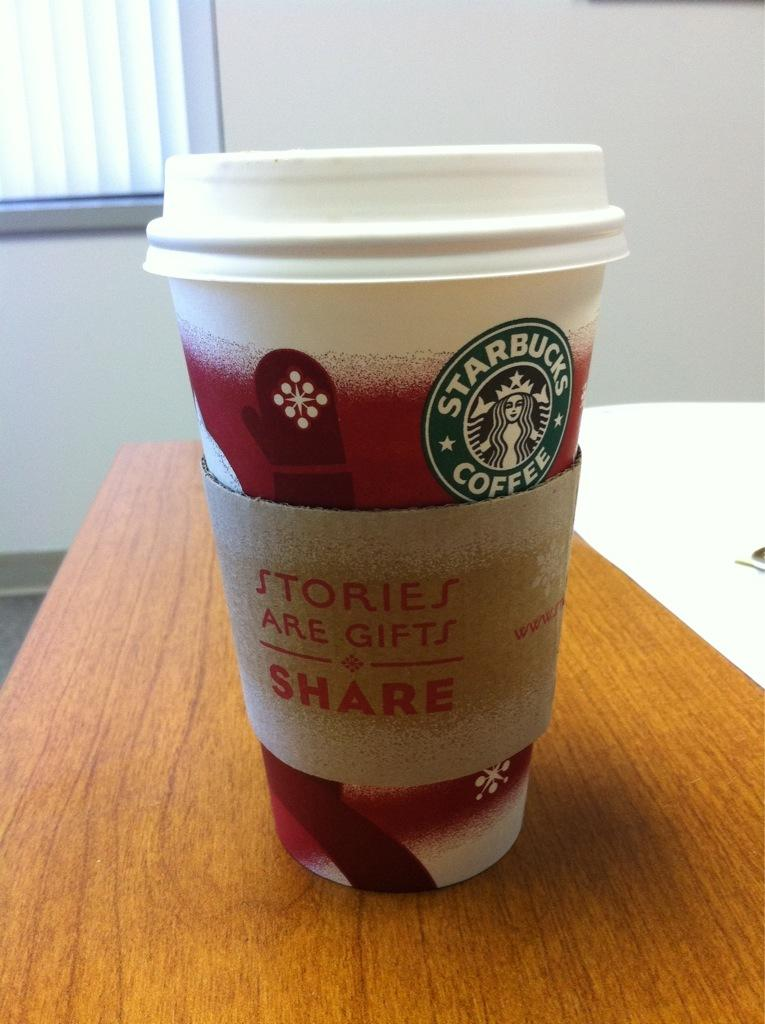What is the main object in the image? There is a Starbucks coffee cup in the image. Where is the coffee cup located? The coffee cup is on a table. What type of grain is visible in the image? There is no grain present in the image; it features a Starbucks coffee cup on a table. How many pockets can be seen on the coffee cup? Coffee cups typically do not have pockets, so there are no pockets visible on the Starbucks coffee cup in the image. 